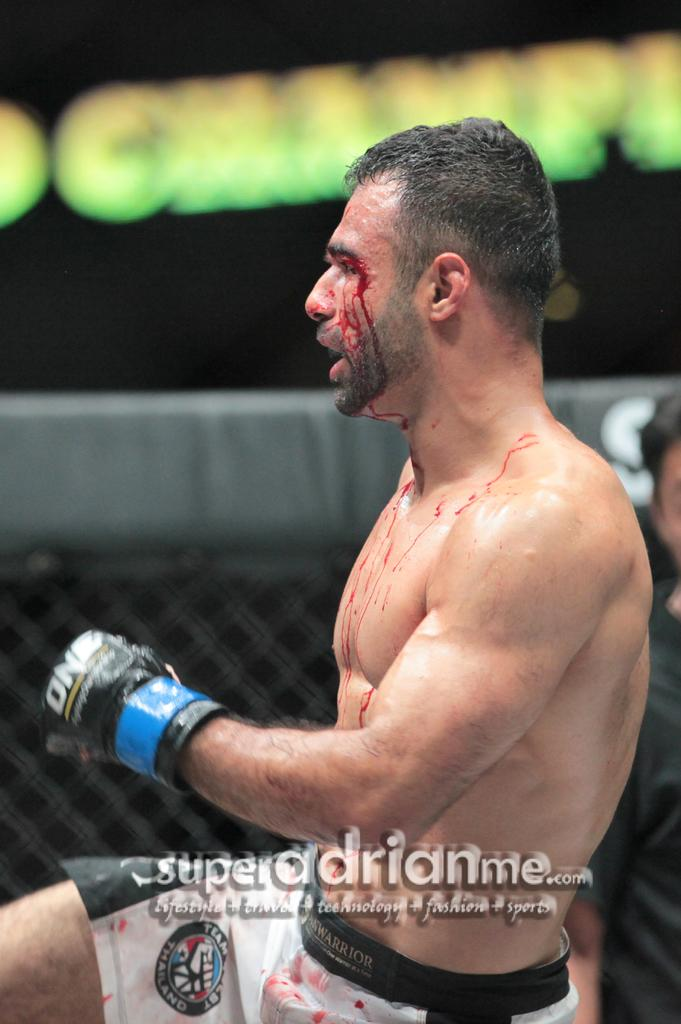How many people are in the image? There are two persons in the image. What can be observed about the background of the image? The background of the image is blurred. Is there any additional information or marking on the image? Yes, there is a watermark on the image. What type of cough medicine is the girl holding in the image? There is no girl present in the image, nor is there any cough medicine or reference to a cough. 